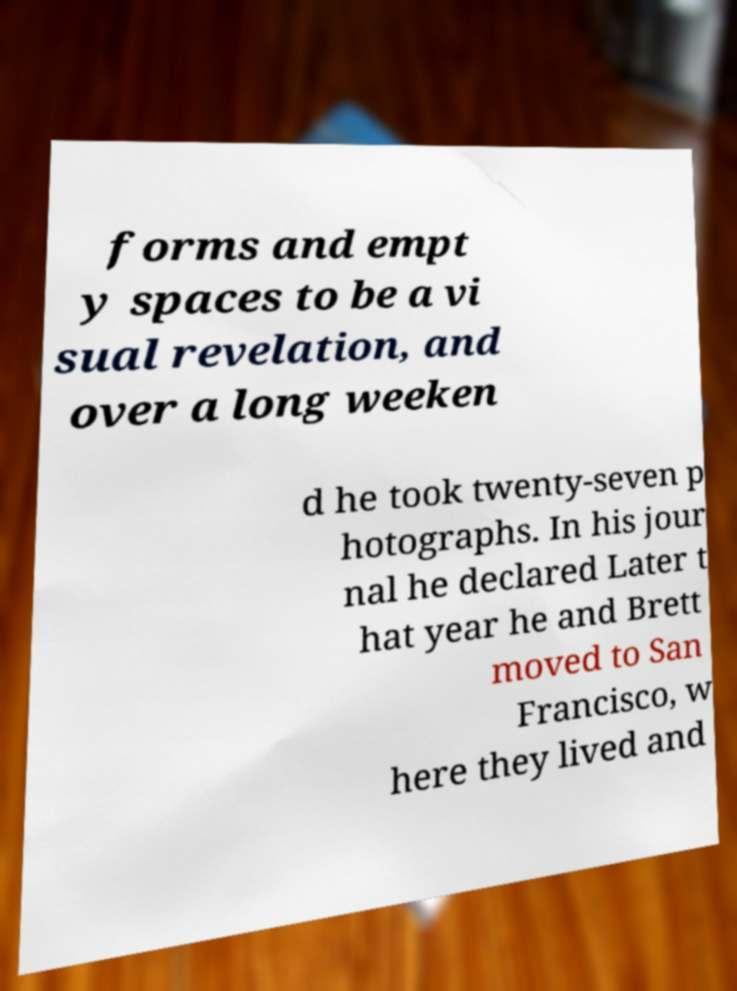What messages or text are displayed in this image? I need them in a readable, typed format. forms and empt y spaces to be a vi sual revelation, and over a long weeken d he took twenty-seven p hotographs. In his jour nal he declared Later t hat year he and Brett moved to San Francisco, w here they lived and 